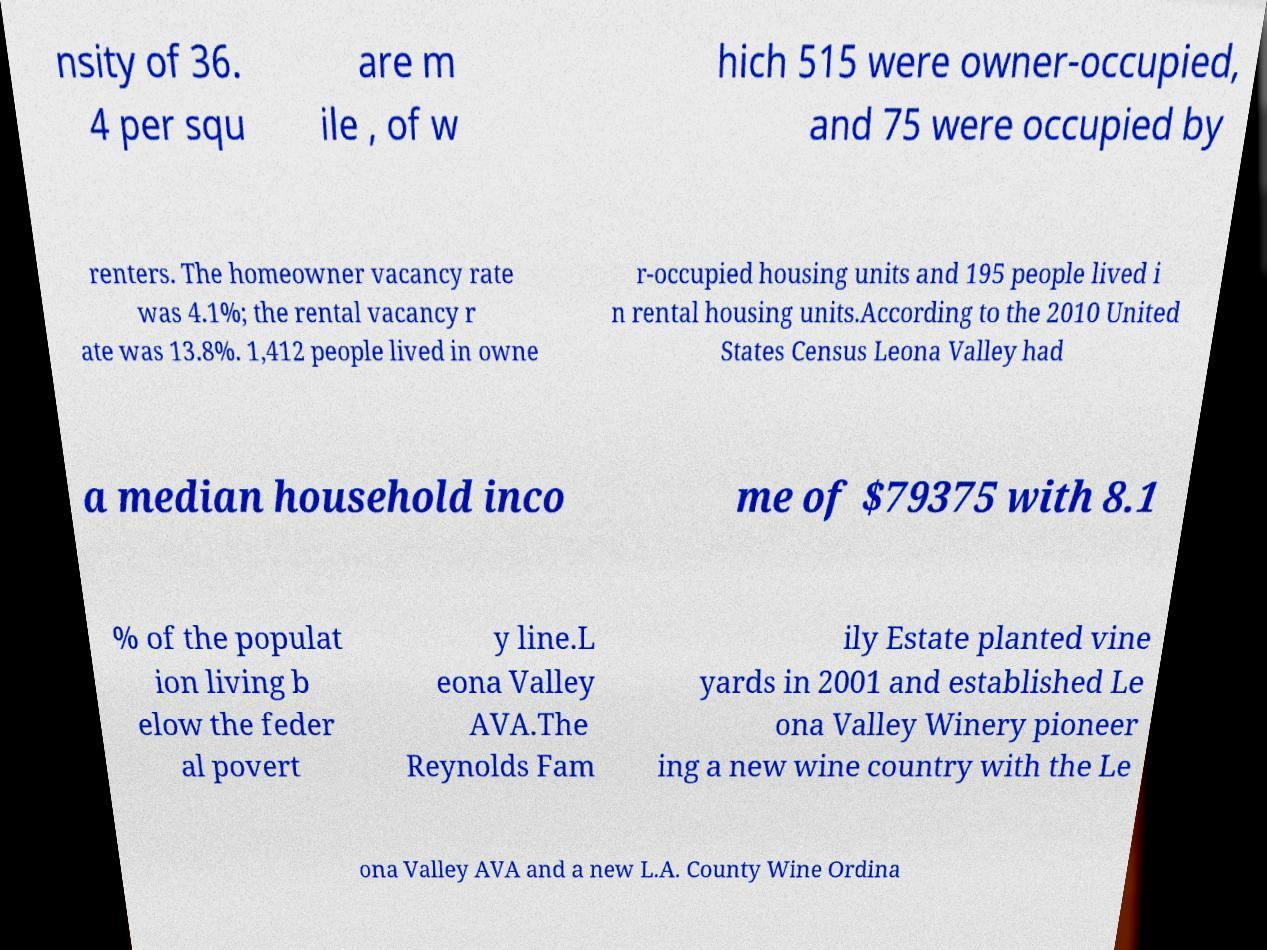Can you read and provide the text displayed in the image?This photo seems to have some interesting text. Can you extract and type it out for me? nsity of 36. 4 per squ are m ile , of w hich 515 were owner-occupied, and 75 were occupied by renters. The homeowner vacancy rate was 4.1%; the rental vacancy r ate was 13.8%. 1,412 people lived in owne r-occupied housing units and 195 people lived i n rental housing units.According to the 2010 United States Census Leona Valley had a median household inco me of $79375 with 8.1 % of the populat ion living b elow the feder al povert y line.L eona Valley AVA.The Reynolds Fam ily Estate planted vine yards in 2001 and established Le ona Valley Winery pioneer ing a new wine country with the Le ona Valley AVA and a new L.A. County Wine Ordina 